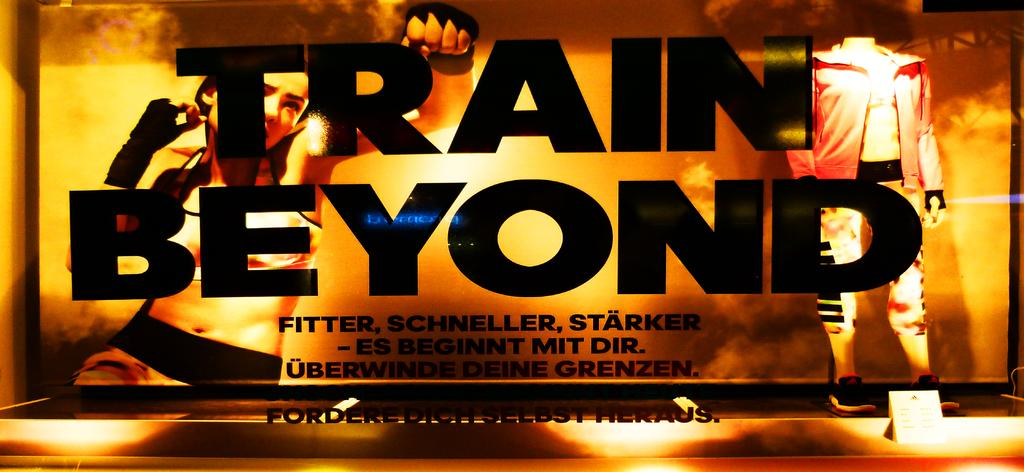<image>
Provide a brief description of the given image. Train Beyond sign that is for working out with 2 people. 